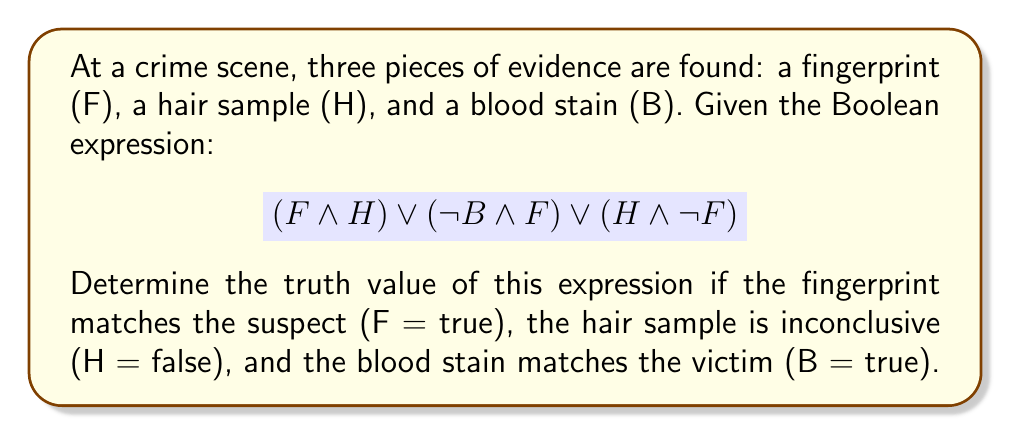Help me with this question. Let's evaluate this Boolean expression step-by-step:

1) We're given:
   F = true
   H = false
   B = true

2) Let's evaluate each part of the expression:

   a) $(F \land H)$:
      true $\land$ false = false

   b) $(\lnot B \land F)$:
      $\lnot$ true $\land$ true = false $\land$ true = false

   c) $(H \land \lnot F)$:
      false $\land$ $\lnot$ true = false $\land$ false = false

3) Now our expression looks like:

   false $\lor$ false $\lor$ false

4) Applying the $\lor$ (OR) operation:

   false $\lor$ false = false
   false $\lor$ false = false

5) Therefore, the entire expression evaluates to false.

This means that none of the conditions in the Boolean expression are satisfied given the evidence at the crime scene.
Answer: False 